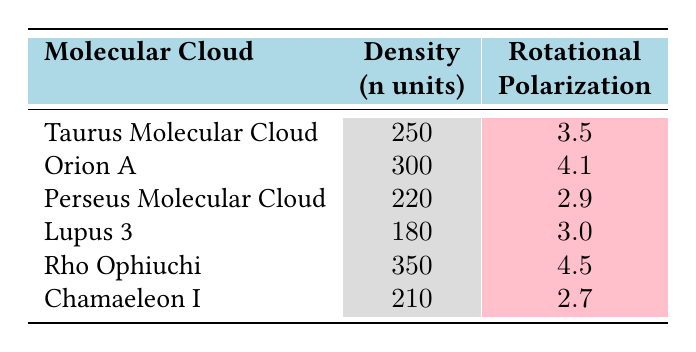What is the rotational polarization measurement for Orion A? The table indicates that the rotational polarization measurement for Orion A is located in the second row under the 'Rotational Polarization' column, which shows the value as 4.1.
Answer: 4.1 Which molecular cloud has the highest density? Looking through the 'Density' column, Rho Ophiuchi has the highest density value of 350 n units, as it is the maximum number listed in that column across all entries.
Answer: Rho Ophiuchi What is the average density of all the molecular clouds listed? To find the average density, we sum all the density values: (250 + 300 + 220 + 180 + 350 + 210) = 1510, then divide by the number of clouds, which is 6: 1510 / 6 = 251.67.
Answer: 251.67 Is the rotational polarization measurement for the Perseus Molecular Cloud greater than that of Lupus 3? The table shows Perseus Molecular Cloud with a measurement of 2.9 and Lupus 3 with 3.0. Since 2.9 is less than 3.0, the statement is false.
Answer: No What is the difference between the highest and lowest rotational polarization measurements? The highest rotational polarization is 4.5 from Rho Ophiuchi, and the lowest is 2.7 from Chamaeleon I. The difference is 4.5 - 2.7 = 1.8.
Answer: 1.8 Which molecular cloud(s) have a density less than 250 n units? Filtering through the 'Density' column, we find that Lupus 3 (180 n units), Perseus Molecular Cloud (220 n units), and Chamaeleon I (210 n units) all have densities less than 250 n units.
Answer: Lupus 3, Perseus Molecular Cloud, Chamaeleon I Is there a molecular cloud with a rotation polarization measurement of exactly 3.0? The table reveals that Lupus 3 has a rotational polarization measurement of 3.0, confirming that there is indeed a cloud with that measurement.
Answer: Yes What is the sum of the rotational polarization measurements for all molecular clouds? To calculate the total, we sum the measurements: 3.5 + 4.1 + 2.9 + 3.0 + 4.5 + 2.7 = 20.7.
Answer: 20.7 